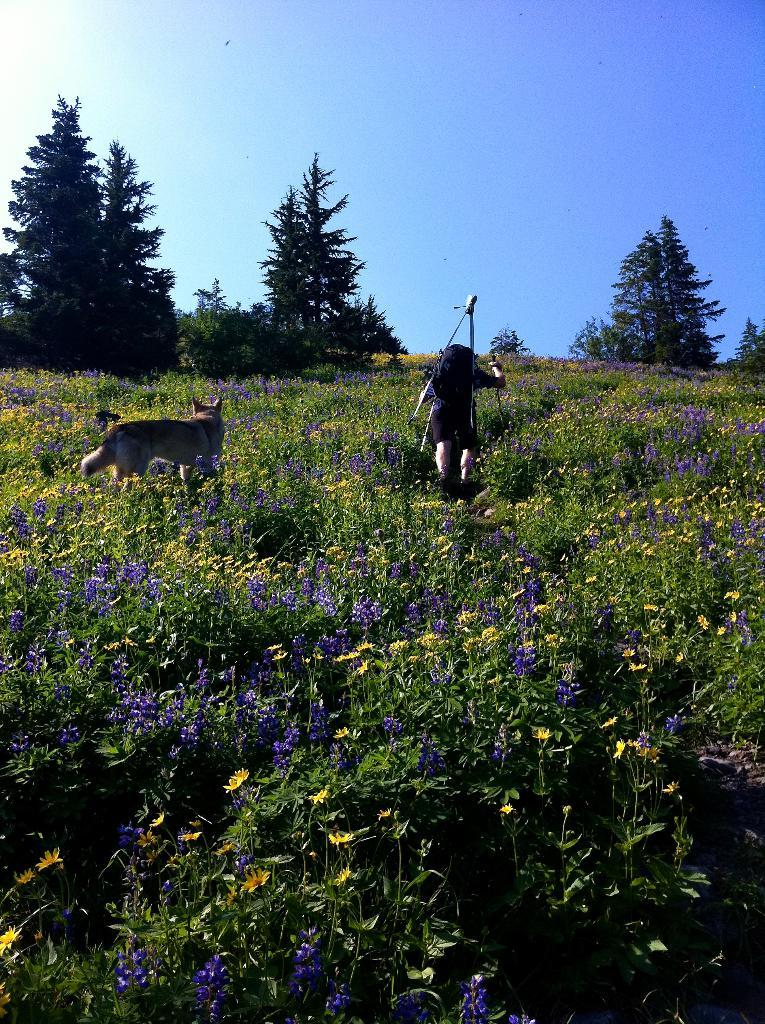What type of animal is in the image? There is a dog in the image. Who or what else is in the image? There is a person in the image. Where are the dog and person located? Both the dog and person are on the ground. What type of vegetation can be seen in the image? There are trees and plants with flowers in the image. What can be seen in the background of the image? The sky is visible in the background of the image. How many islands can be seen in the image? There are no islands present in the image. What type of hand is resting on the dog's head in the image? There is no hand resting on the dog's head in the image. 